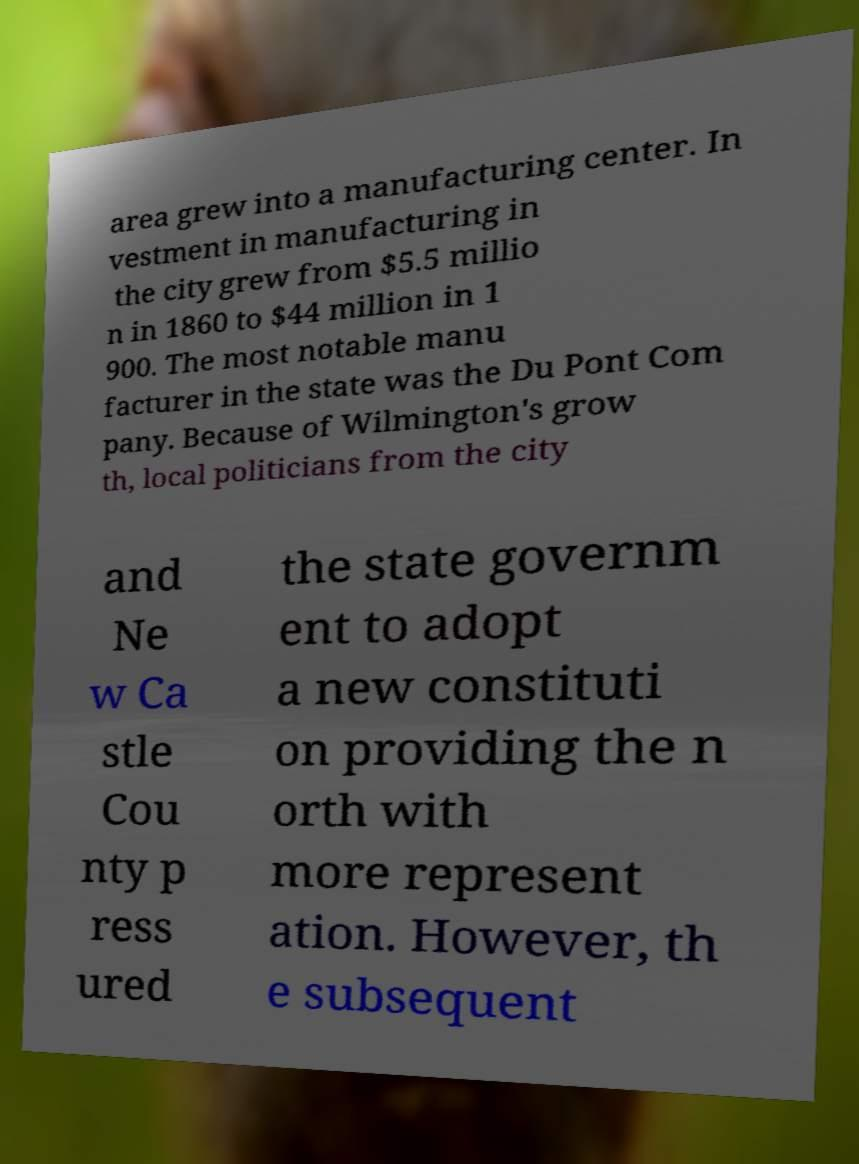Can you read and provide the text displayed in the image?This photo seems to have some interesting text. Can you extract and type it out for me? area grew into a manufacturing center. In vestment in manufacturing in the city grew from $5.5 millio n in 1860 to $44 million in 1 900. The most notable manu facturer in the state was the Du Pont Com pany. Because of Wilmington's grow th, local politicians from the city and Ne w Ca stle Cou nty p ress ured the state governm ent to adopt a new constituti on providing the n orth with more represent ation. However, th e subsequent 